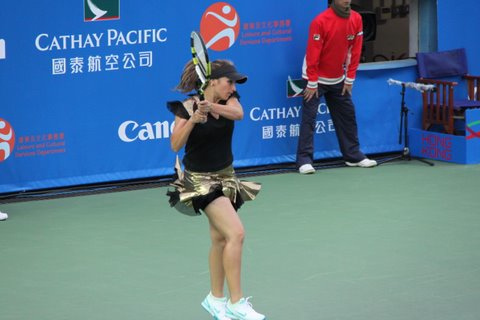Extract all visible text content from this image. C CATHAY PACIFIC Can CATHAY C 